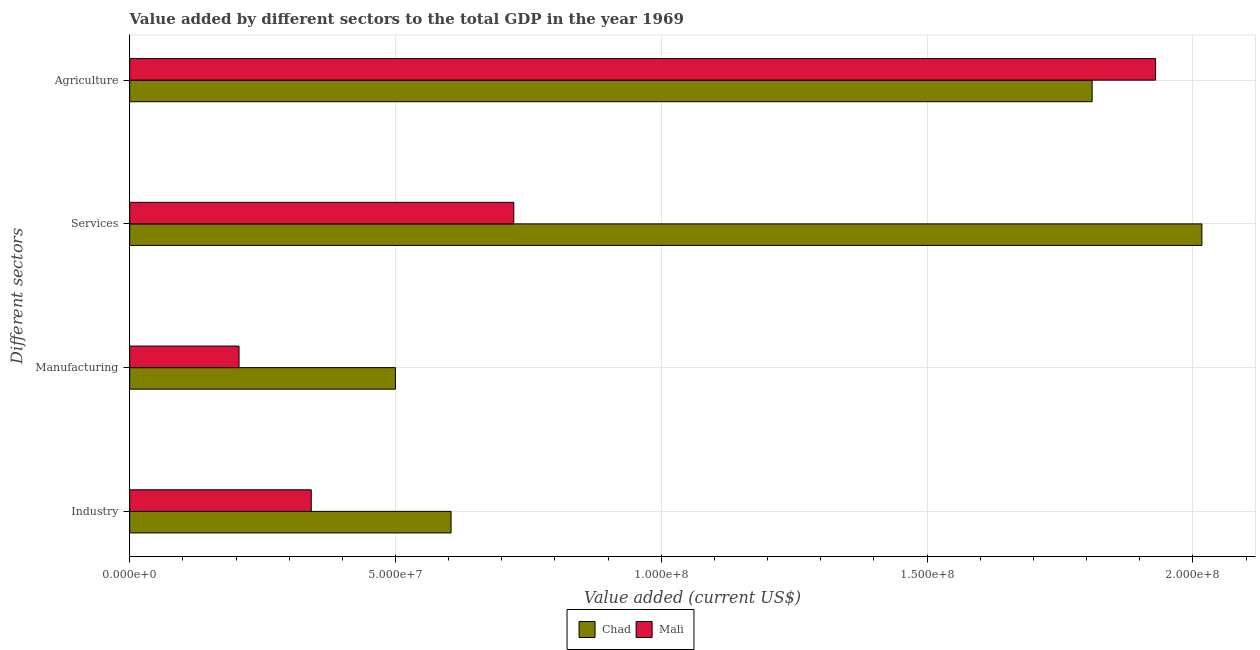Are the number of bars on each tick of the Y-axis equal?
Your response must be concise. Yes. What is the label of the 3rd group of bars from the top?
Provide a short and direct response. Manufacturing. What is the value added by agricultural sector in Mali?
Make the answer very short. 1.93e+08. Across all countries, what is the maximum value added by industrial sector?
Your answer should be compact. 6.05e+07. Across all countries, what is the minimum value added by manufacturing sector?
Ensure brevity in your answer.  2.06e+07. In which country was the value added by services sector maximum?
Provide a short and direct response. Chad. In which country was the value added by agricultural sector minimum?
Keep it short and to the point. Chad. What is the total value added by services sector in the graph?
Make the answer very short. 2.74e+08. What is the difference between the value added by manufacturing sector in Chad and that in Mali?
Keep it short and to the point. 2.94e+07. What is the difference between the value added by industrial sector in Mali and the value added by manufacturing sector in Chad?
Provide a succinct answer. -1.58e+07. What is the average value added by agricultural sector per country?
Provide a short and direct response. 1.87e+08. What is the difference between the value added by industrial sector and value added by services sector in Chad?
Keep it short and to the point. -1.41e+08. In how many countries, is the value added by manufacturing sector greater than 60000000 US$?
Your answer should be very brief. 0. What is the ratio of the value added by industrial sector in Mali to that in Chad?
Offer a terse response. 0.56. Is the difference between the value added by manufacturing sector in Mali and Chad greater than the difference between the value added by industrial sector in Mali and Chad?
Your answer should be very brief. No. What is the difference between the highest and the second highest value added by services sector?
Your answer should be compact. 1.29e+08. What is the difference between the highest and the lowest value added by industrial sector?
Provide a short and direct response. 2.63e+07. In how many countries, is the value added by industrial sector greater than the average value added by industrial sector taken over all countries?
Offer a very short reply. 1. Is the sum of the value added by industrial sector in Mali and Chad greater than the maximum value added by services sector across all countries?
Give a very brief answer. No. What does the 1st bar from the top in Manufacturing represents?
Your answer should be compact. Mali. What does the 1st bar from the bottom in Manufacturing represents?
Ensure brevity in your answer.  Chad. Is it the case that in every country, the sum of the value added by industrial sector and value added by manufacturing sector is greater than the value added by services sector?
Ensure brevity in your answer.  No. How many bars are there?
Give a very brief answer. 8. Are all the bars in the graph horizontal?
Ensure brevity in your answer.  Yes. Are the values on the major ticks of X-axis written in scientific E-notation?
Provide a short and direct response. Yes. Does the graph contain any zero values?
Offer a very short reply. No. Does the graph contain grids?
Your answer should be compact. Yes. Where does the legend appear in the graph?
Ensure brevity in your answer.  Bottom center. How are the legend labels stacked?
Make the answer very short. Horizontal. What is the title of the graph?
Provide a succinct answer. Value added by different sectors to the total GDP in the year 1969. Does "St. Vincent and the Grenadines" appear as one of the legend labels in the graph?
Give a very brief answer. No. What is the label or title of the X-axis?
Ensure brevity in your answer.  Value added (current US$). What is the label or title of the Y-axis?
Your answer should be compact. Different sectors. What is the Value added (current US$) in Chad in Industry?
Your answer should be compact. 6.05e+07. What is the Value added (current US$) of Mali in Industry?
Make the answer very short. 3.42e+07. What is the Value added (current US$) in Chad in Manufacturing?
Your response must be concise. 5.00e+07. What is the Value added (current US$) of Mali in Manufacturing?
Make the answer very short. 2.06e+07. What is the Value added (current US$) in Chad in Services?
Ensure brevity in your answer.  2.02e+08. What is the Value added (current US$) of Mali in Services?
Your answer should be very brief. 7.23e+07. What is the Value added (current US$) of Chad in Agriculture?
Make the answer very short. 1.81e+08. What is the Value added (current US$) in Mali in Agriculture?
Give a very brief answer. 1.93e+08. Across all Different sectors, what is the maximum Value added (current US$) of Chad?
Your answer should be very brief. 2.02e+08. Across all Different sectors, what is the maximum Value added (current US$) in Mali?
Make the answer very short. 1.93e+08. Across all Different sectors, what is the minimum Value added (current US$) in Chad?
Ensure brevity in your answer.  5.00e+07. Across all Different sectors, what is the minimum Value added (current US$) in Mali?
Offer a terse response. 2.06e+07. What is the total Value added (current US$) of Chad in the graph?
Ensure brevity in your answer.  4.93e+08. What is the total Value added (current US$) of Mali in the graph?
Your response must be concise. 3.20e+08. What is the difference between the Value added (current US$) of Chad in Industry and that in Manufacturing?
Your answer should be very brief. 1.05e+07. What is the difference between the Value added (current US$) of Mali in Industry and that in Manufacturing?
Offer a very short reply. 1.36e+07. What is the difference between the Value added (current US$) in Chad in Industry and that in Services?
Offer a terse response. -1.41e+08. What is the difference between the Value added (current US$) in Mali in Industry and that in Services?
Your answer should be very brief. -3.81e+07. What is the difference between the Value added (current US$) in Chad in Industry and that in Agriculture?
Make the answer very short. -1.21e+08. What is the difference between the Value added (current US$) in Mali in Industry and that in Agriculture?
Your answer should be compact. -1.59e+08. What is the difference between the Value added (current US$) of Chad in Manufacturing and that in Services?
Offer a terse response. -1.52e+08. What is the difference between the Value added (current US$) in Mali in Manufacturing and that in Services?
Your response must be concise. -5.17e+07. What is the difference between the Value added (current US$) of Chad in Manufacturing and that in Agriculture?
Provide a short and direct response. -1.31e+08. What is the difference between the Value added (current US$) in Mali in Manufacturing and that in Agriculture?
Your answer should be very brief. -1.72e+08. What is the difference between the Value added (current US$) of Chad in Services and that in Agriculture?
Offer a terse response. 2.06e+07. What is the difference between the Value added (current US$) in Mali in Services and that in Agriculture?
Your answer should be compact. -1.21e+08. What is the difference between the Value added (current US$) in Chad in Industry and the Value added (current US$) in Mali in Manufacturing?
Ensure brevity in your answer.  3.99e+07. What is the difference between the Value added (current US$) of Chad in Industry and the Value added (current US$) of Mali in Services?
Make the answer very short. -1.18e+07. What is the difference between the Value added (current US$) of Chad in Industry and the Value added (current US$) of Mali in Agriculture?
Keep it short and to the point. -1.33e+08. What is the difference between the Value added (current US$) in Chad in Manufacturing and the Value added (current US$) in Mali in Services?
Offer a terse response. -2.23e+07. What is the difference between the Value added (current US$) in Chad in Manufacturing and the Value added (current US$) in Mali in Agriculture?
Your answer should be compact. -1.43e+08. What is the difference between the Value added (current US$) of Chad in Services and the Value added (current US$) of Mali in Agriculture?
Provide a succinct answer. 8.71e+06. What is the average Value added (current US$) in Chad per Different sectors?
Offer a terse response. 1.23e+08. What is the average Value added (current US$) in Mali per Different sectors?
Offer a terse response. 8.00e+07. What is the difference between the Value added (current US$) of Chad and Value added (current US$) of Mali in Industry?
Your answer should be very brief. 2.63e+07. What is the difference between the Value added (current US$) in Chad and Value added (current US$) in Mali in Manufacturing?
Offer a terse response. 2.94e+07. What is the difference between the Value added (current US$) in Chad and Value added (current US$) in Mali in Services?
Your answer should be very brief. 1.29e+08. What is the difference between the Value added (current US$) of Chad and Value added (current US$) of Mali in Agriculture?
Offer a very short reply. -1.19e+07. What is the ratio of the Value added (current US$) in Chad in Industry to that in Manufacturing?
Your answer should be very brief. 1.21. What is the ratio of the Value added (current US$) of Mali in Industry to that in Manufacturing?
Your response must be concise. 1.66. What is the ratio of the Value added (current US$) of Chad in Industry to that in Services?
Offer a terse response. 0.3. What is the ratio of the Value added (current US$) in Mali in Industry to that in Services?
Your answer should be very brief. 0.47. What is the ratio of the Value added (current US$) in Chad in Industry to that in Agriculture?
Make the answer very short. 0.33. What is the ratio of the Value added (current US$) of Mali in Industry to that in Agriculture?
Offer a terse response. 0.18. What is the ratio of the Value added (current US$) of Chad in Manufacturing to that in Services?
Offer a very short reply. 0.25. What is the ratio of the Value added (current US$) of Mali in Manufacturing to that in Services?
Offer a terse response. 0.28. What is the ratio of the Value added (current US$) in Chad in Manufacturing to that in Agriculture?
Offer a terse response. 0.28. What is the ratio of the Value added (current US$) in Mali in Manufacturing to that in Agriculture?
Your answer should be very brief. 0.11. What is the ratio of the Value added (current US$) of Chad in Services to that in Agriculture?
Ensure brevity in your answer.  1.11. What is the ratio of the Value added (current US$) of Mali in Services to that in Agriculture?
Give a very brief answer. 0.37. What is the difference between the highest and the second highest Value added (current US$) in Chad?
Keep it short and to the point. 2.06e+07. What is the difference between the highest and the second highest Value added (current US$) of Mali?
Your response must be concise. 1.21e+08. What is the difference between the highest and the lowest Value added (current US$) in Chad?
Provide a succinct answer. 1.52e+08. What is the difference between the highest and the lowest Value added (current US$) in Mali?
Provide a succinct answer. 1.72e+08. 